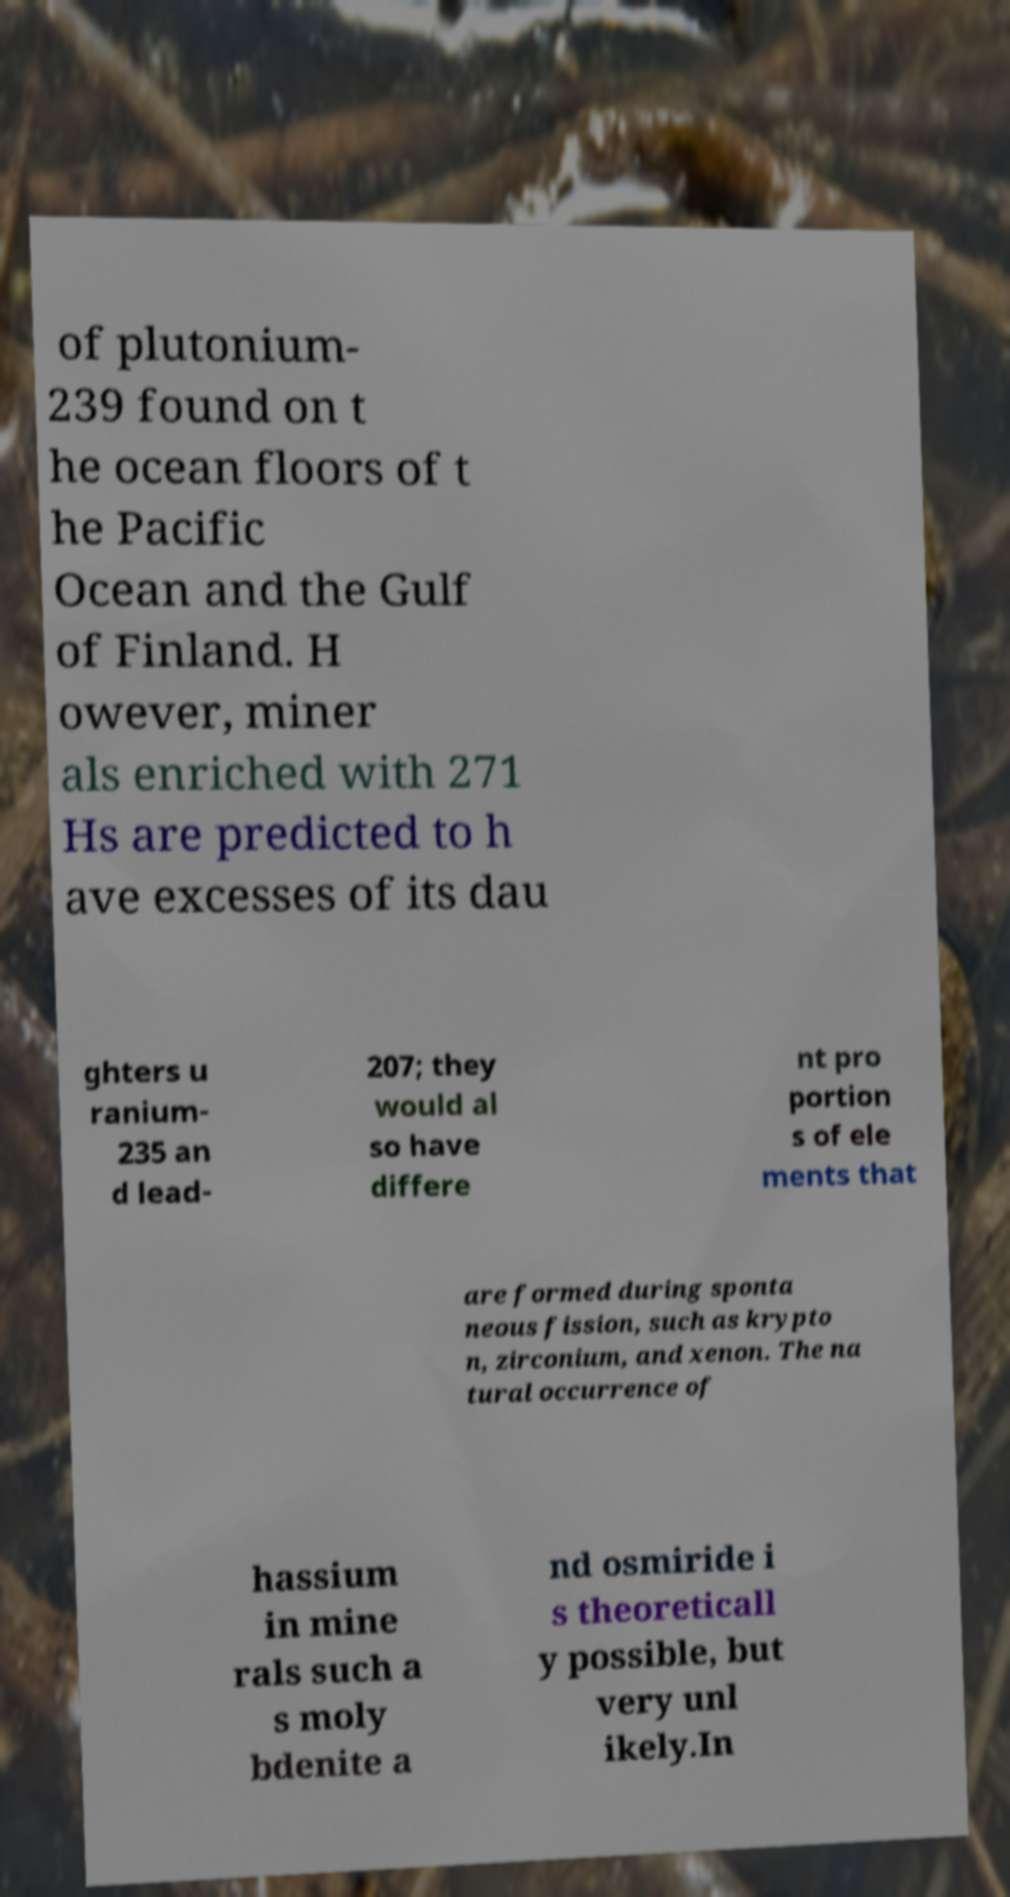Could you assist in decoding the text presented in this image and type it out clearly? of plutonium- 239 found on t he ocean floors of t he Pacific Ocean and the Gulf of Finland. H owever, miner als enriched with 271 Hs are predicted to h ave excesses of its dau ghters u ranium- 235 an d lead- 207; they would al so have differe nt pro portion s of ele ments that are formed during sponta neous fission, such as krypto n, zirconium, and xenon. The na tural occurrence of hassium in mine rals such a s moly bdenite a nd osmiride i s theoreticall y possible, but very unl ikely.In 